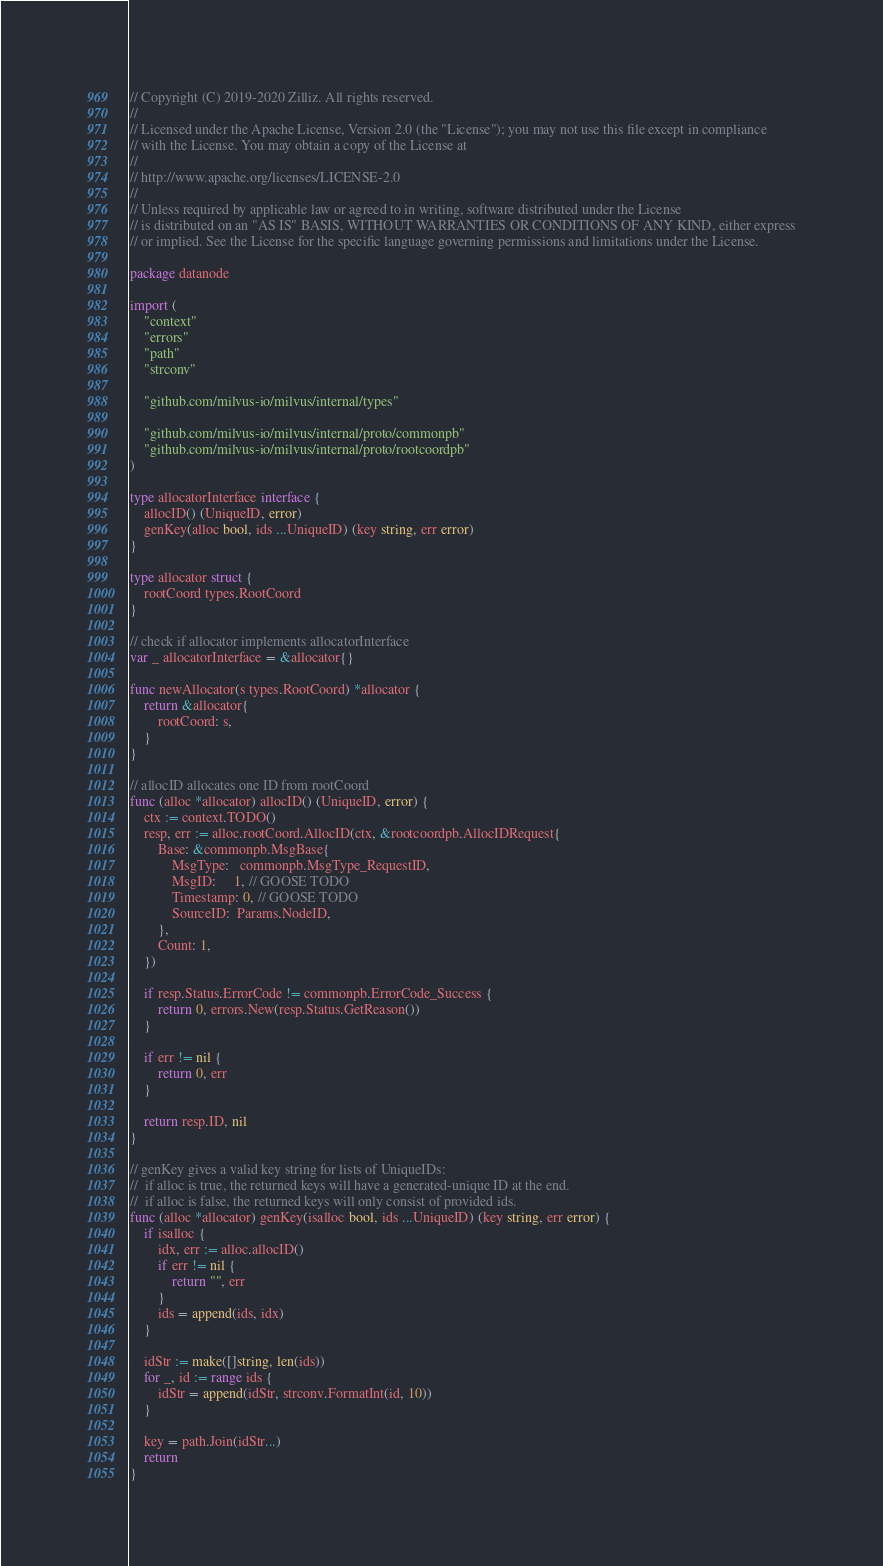<code> <loc_0><loc_0><loc_500><loc_500><_Go_>// Copyright (C) 2019-2020 Zilliz. All rights reserved.
//
// Licensed under the Apache License, Version 2.0 (the "License"); you may not use this file except in compliance
// with the License. You may obtain a copy of the License at
//
// http://www.apache.org/licenses/LICENSE-2.0
//
// Unless required by applicable law or agreed to in writing, software distributed under the License
// is distributed on an "AS IS" BASIS, WITHOUT WARRANTIES OR CONDITIONS OF ANY KIND, either express
// or implied. See the License for the specific language governing permissions and limitations under the License.

package datanode

import (
	"context"
	"errors"
	"path"
	"strconv"

	"github.com/milvus-io/milvus/internal/types"

	"github.com/milvus-io/milvus/internal/proto/commonpb"
	"github.com/milvus-io/milvus/internal/proto/rootcoordpb"
)

type allocatorInterface interface {
	allocID() (UniqueID, error)
	genKey(alloc bool, ids ...UniqueID) (key string, err error)
}

type allocator struct {
	rootCoord types.RootCoord
}

// check if allocator implements allocatorInterface
var _ allocatorInterface = &allocator{}

func newAllocator(s types.RootCoord) *allocator {
	return &allocator{
		rootCoord: s,
	}
}

// allocID allocates one ID from rootCoord
func (alloc *allocator) allocID() (UniqueID, error) {
	ctx := context.TODO()
	resp, err := alloc.rootCoord.AllocID(ctx, &rootcoordpb.AllocIDRequest{
		Base: &commonpb.MsgBase{
			MsgType:   commonpb.MsgType_RequestID,
			MsgID:     1, // GOOSE TODO
			Timestamp: 0, // GOOSE TODO
			SourceID:  Params.NodeID,
		},
		Count: 1,
	})

	if resp.Status.ErrorCode != commonpb.ErrorCode_Success {
		return 0, errors.New(resp.Status.GetReason())
	}

	if err != nil {
		return 0, err
	}

	return resp.ID, nil
}

// genKey gives a valid key string for lists of UniqueIDs:
//  if alloc is true, the returned keys will have a generated-unique ID at the end.
//  if alloc is false, the returned keys will only consist of provided ids.
func (alloc *allocator) genKey(isalloc bool, ids ...UniqueID) (key string, err error) {
	if isalloc {
		idx, err := alloc.allocID()
		if err != nil {
			return "", err
		}
		ids = append(ids, idx)
	}

	idStr := make([]string, len(ids))
	for _, id := range ids {
		idStr = append(idStr, strconv.FormatInt(id, 10))
	}

	key = path.Join(idStr...)
	return
}
</code> 